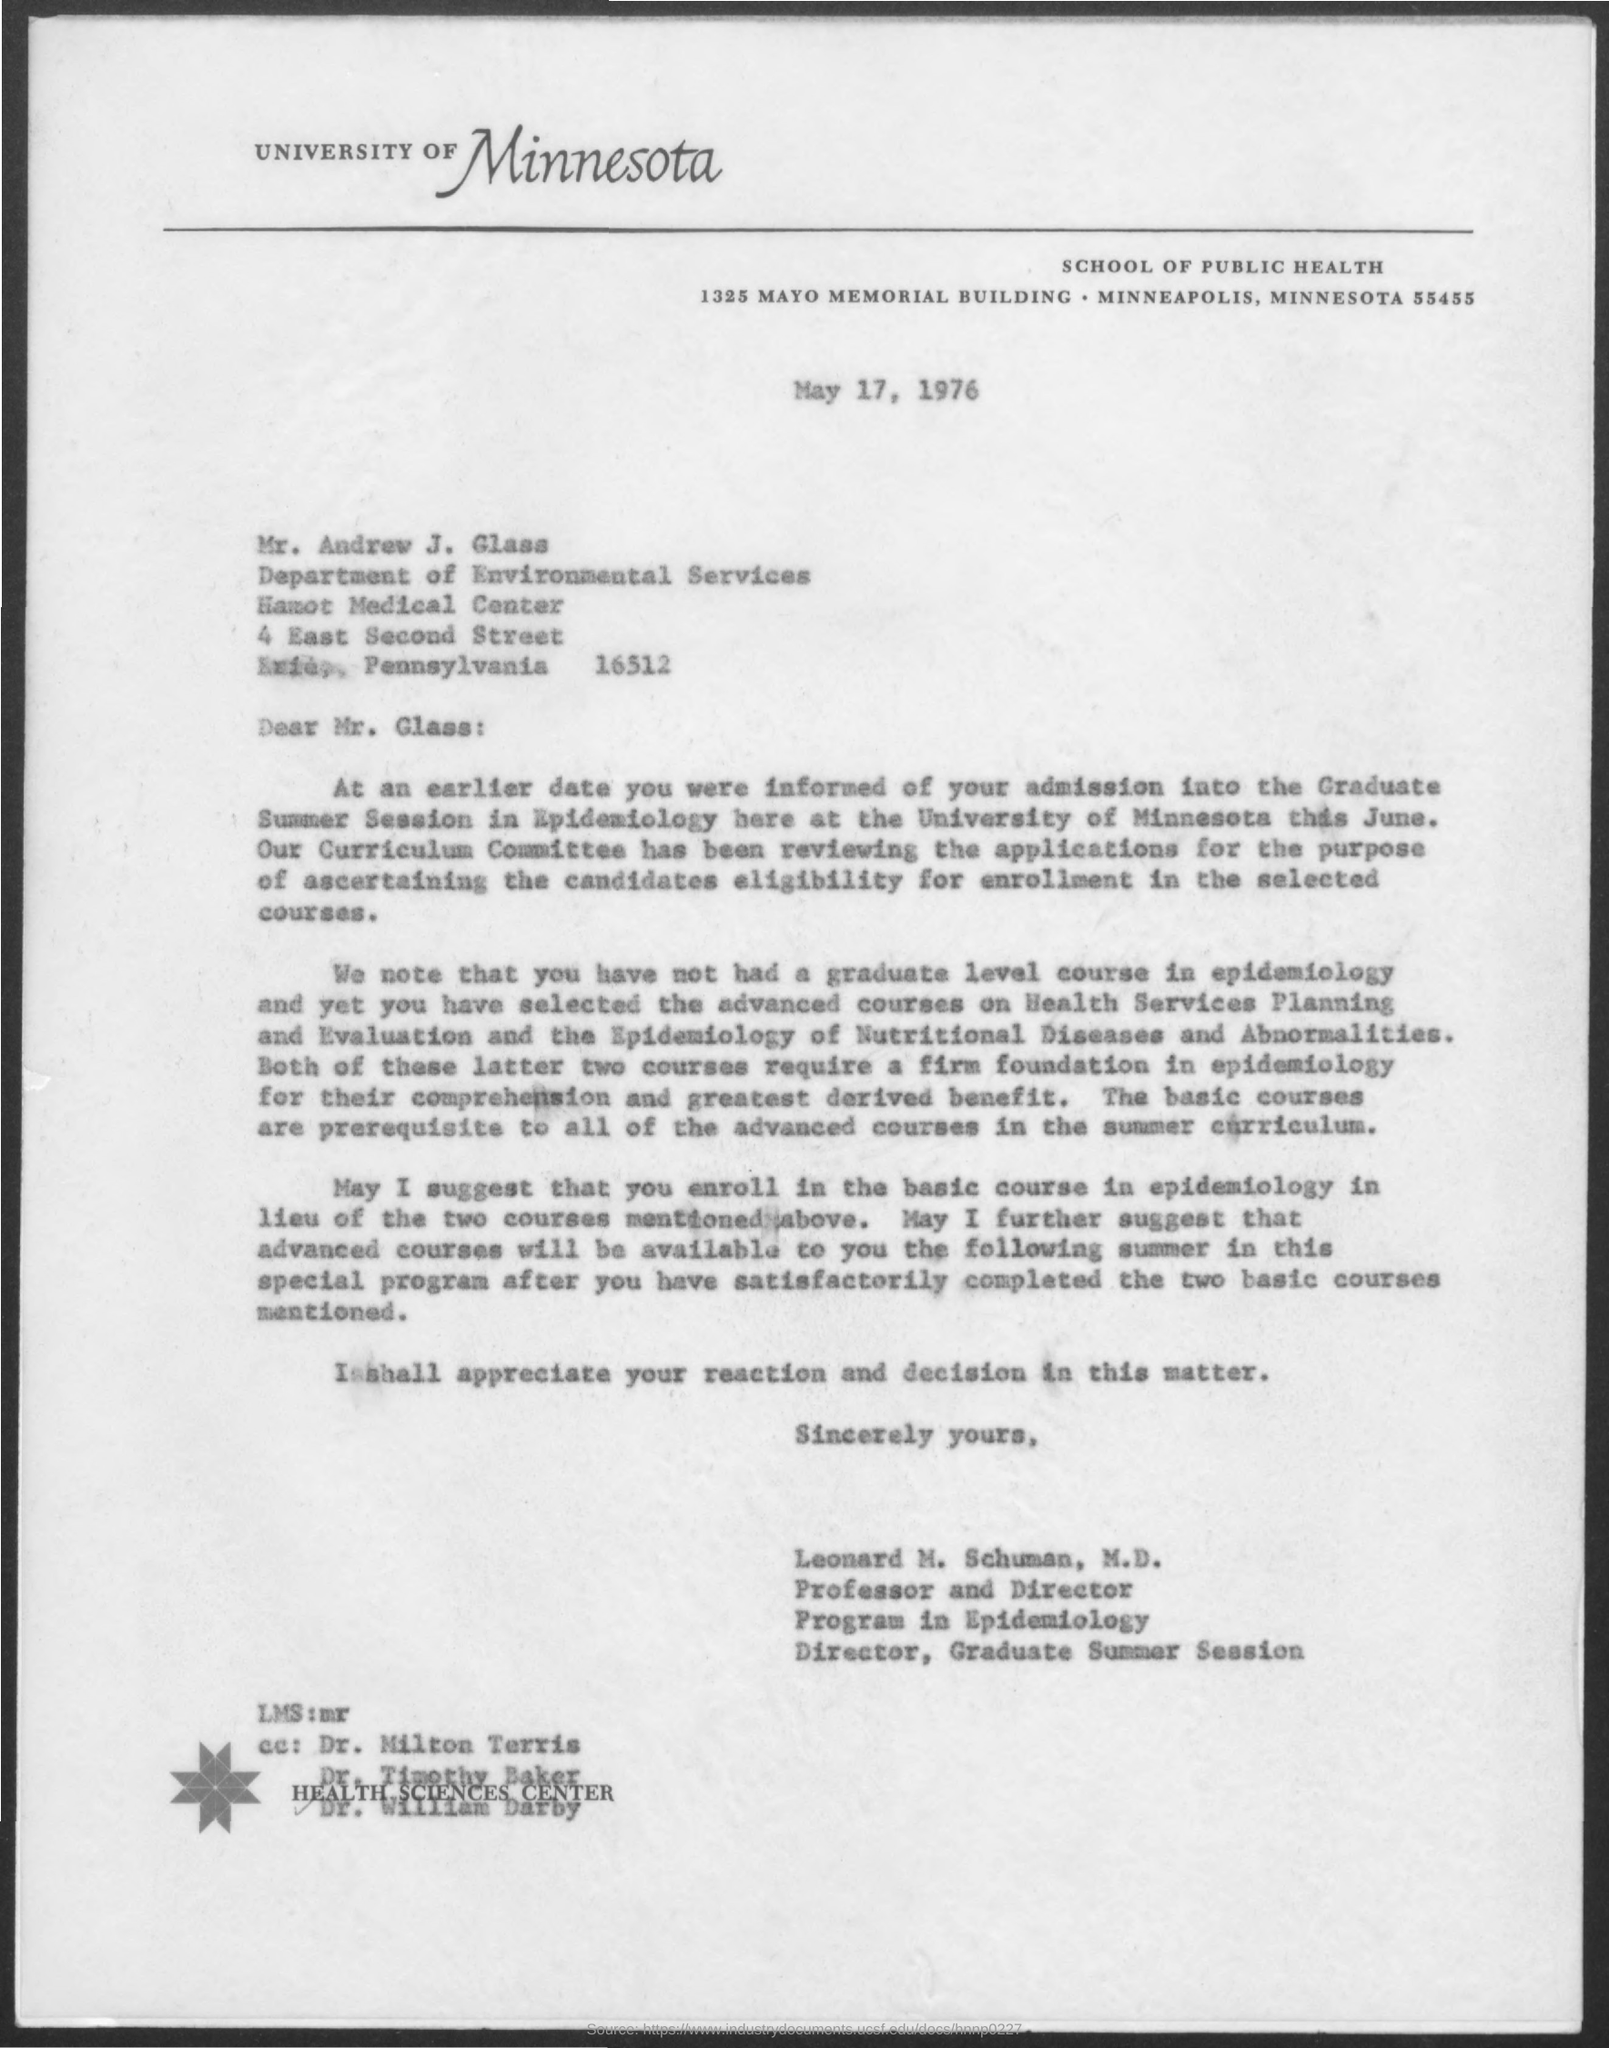Highlight a few significant elements in this photo. The Memorandum was dated on May 17, 1976. 